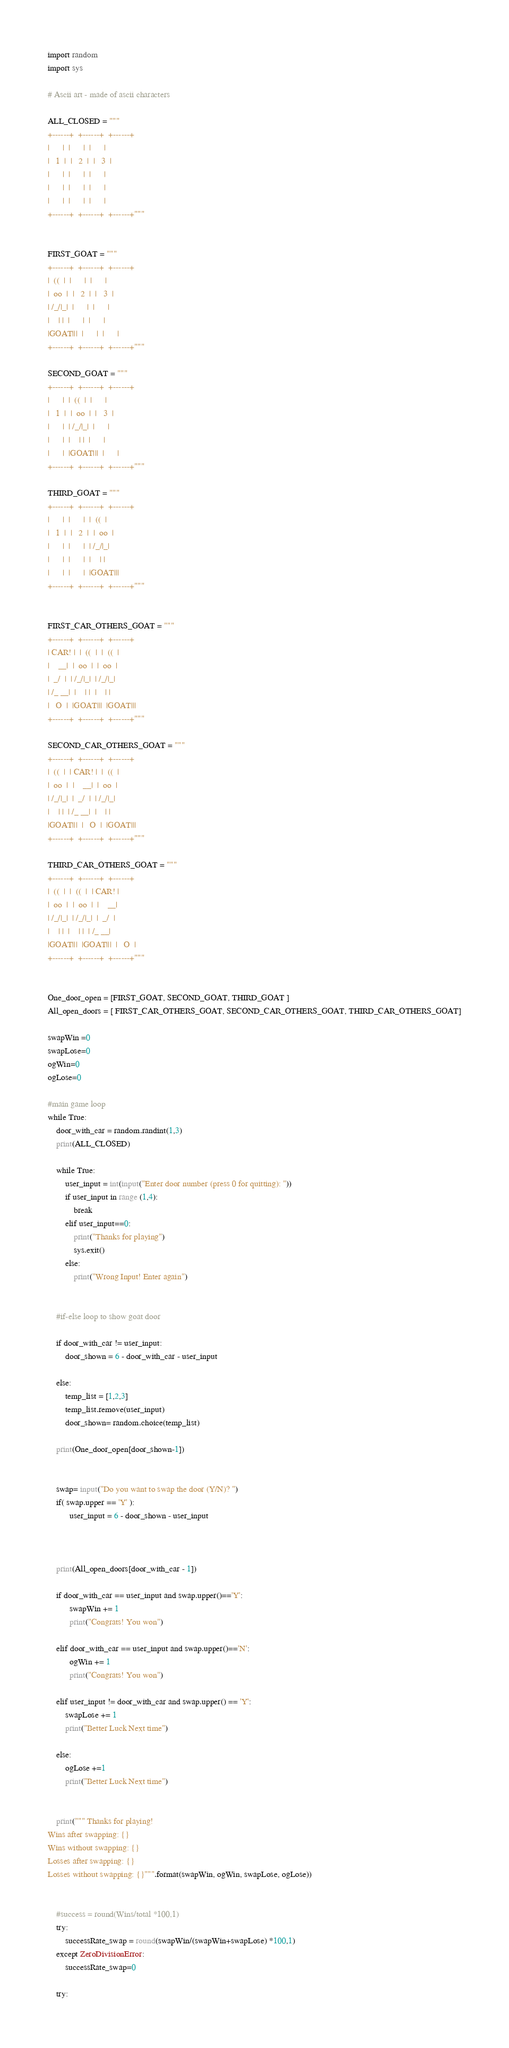Convert code to text. <code><loc_0><loc_0><loc_500><loc_500><_Python_>import random
import sys

# Ascii art - made of ascii characters

ALL_CLOSED = """
+------+  +------+  +------+
|      |  |      |  |      |
|   1  |  |   2  |  |   3  |
|      |  |      |  |      |
|      |  |      |  |      |
|      |  |      |  |      |
+------+  +------+  +------+"""


FIRST_GOAT = """
+------+  +------+  +------+
|  ((  |  |      |  |      |
|  oo  |  |   2  |  |   3  |
| /_/|_|  |      |  |      |
|    | |  |      |  |      |
|GOAT|||  |      |  |      |
+------+  +------+  +------+"""

SECOND_GOAT = """
+------+  +------+  +------+
|      |  |  ((  |  |      |
|   1  |  |  oo  |  |   3  |
|      |  | /_/|_|  |      |
|      |  |    | |  |      |
|      |  |GOAT|||  |      |
+------+  +------+  +------+"""

THIRD_GOAT = """
+------+  +------+  +------+
|      |  |      |  |  ((  |
|   1  |  |   2  |  |  oo  |
|      |  |      |  | /_/|_|
|      |  |      |  |    | |
|      |  |      |  |GOAT|||
+------+  +------+  +------+"""


FIRST_CAR_OTHERS_GOAT = """
+------+  +------+  +------+
| CAR! |  |  ((  |  |  ((  |
|    __|  |  oo  |  |  oo  |
|  _/  |  | /_/|_|  | /_/|_|
| /_ __|  |    | |  |    | |
|   O  |  |GOAT|||  |GOAT|||
+------+  +------+  +------+"""

SECOND_CAR_OTHERS_GOAT = """
+------+  +------+  +------+
|  ((  |  | CAR! |  |  ((  |
|  oo  |  |    __|  |  oo  |
| /_/|_|  |  _/  |  | /_/|_|
|    | |  | /_ __|  |    | |
|GOAT|||  |   O  |  |GOAT|||
+------+  +------+  +------+"""

THIRD_CAR_OTHERS_GOAT = """
+------+  +------+  +------+
|  ((  |  |  ((  |  | CAR! |
|  oo  |  |  oo  |  |    __|
| /_/|_|  | /_/|_|  |  _/  |
|    | |  |    | |  | /_ __|
|GOAT|||  |GOAT|||  |   O  |
+------+  +------+  +------+"""


One_door_open = [FIRST_GOAT, SECOND_GOAT, THIRD_GOAT ]
All_open_doors = [ FIRST_CAR_OTHERS_GOAT, SECOND_CAR_OTHERS_GOAT, THIRD_CAR_OTHERS_GOAT]

swapWin =0
swapLose=0
ogWin=0
ogLose=0

#main game loop
while True:
    door_with_car = random.randint(1,3)
    print(ALL_CLOSED)

    while True:
        user_input = int(input("Enter door number (press 0 for quitting): "))
        if user_input in range (1,4):
            break
        elif user_input==0:
            print("Thanks for playing")
            sys.exit()
        else:
            print("Wrong Input! Enter again")


    #if-else loop to show goat door

    if door_with_car != user_input:
        door_shown = 6 - door_with_car - user_input

    else:
        temp_list = [1,2,3]
        temp_list.remove(user_input)
        door_shown= random.choice(temp_list)

    print(One_door_open[door_shown-1])


    swap= input("Do you want to swap the door (Y/N)? ")
    if( swap.upper == 'Y' ):
          user_input = 6 - door_shown - user_input



    print(All_open_doors[door_with_car - 1])

    if door_with_car == user_input and swap.upper()=='Y':
          swapWin += 1
          print("Congrats! You won")
          
    elif door_with_car == user_input and swap.upper()=='N':
          ogWin += 1
          print("Congrats! You won")

    elif user_input != door_with_car and swap.upper() == 'Y':
        swapLose += 1
        print("Better Luck Next time")

    else:
        ogLose +=1
        print("Better Luck Next time")


    print(""" Thanks for playing!
Wins after swapping: {}
Wins without swapping: {}
Losses after swapping: {}
Losses without swapping: {}""".format(swapWin, ogWin, swapLose, ogLose))


    #success = round(Wins/total *100,1)
    try:
        successRate_swap = round(swapWin/(swapWin+swapLose) *100,1)
    except ZeroDivisionError:
        successRate_swap=0

    try:</code> 